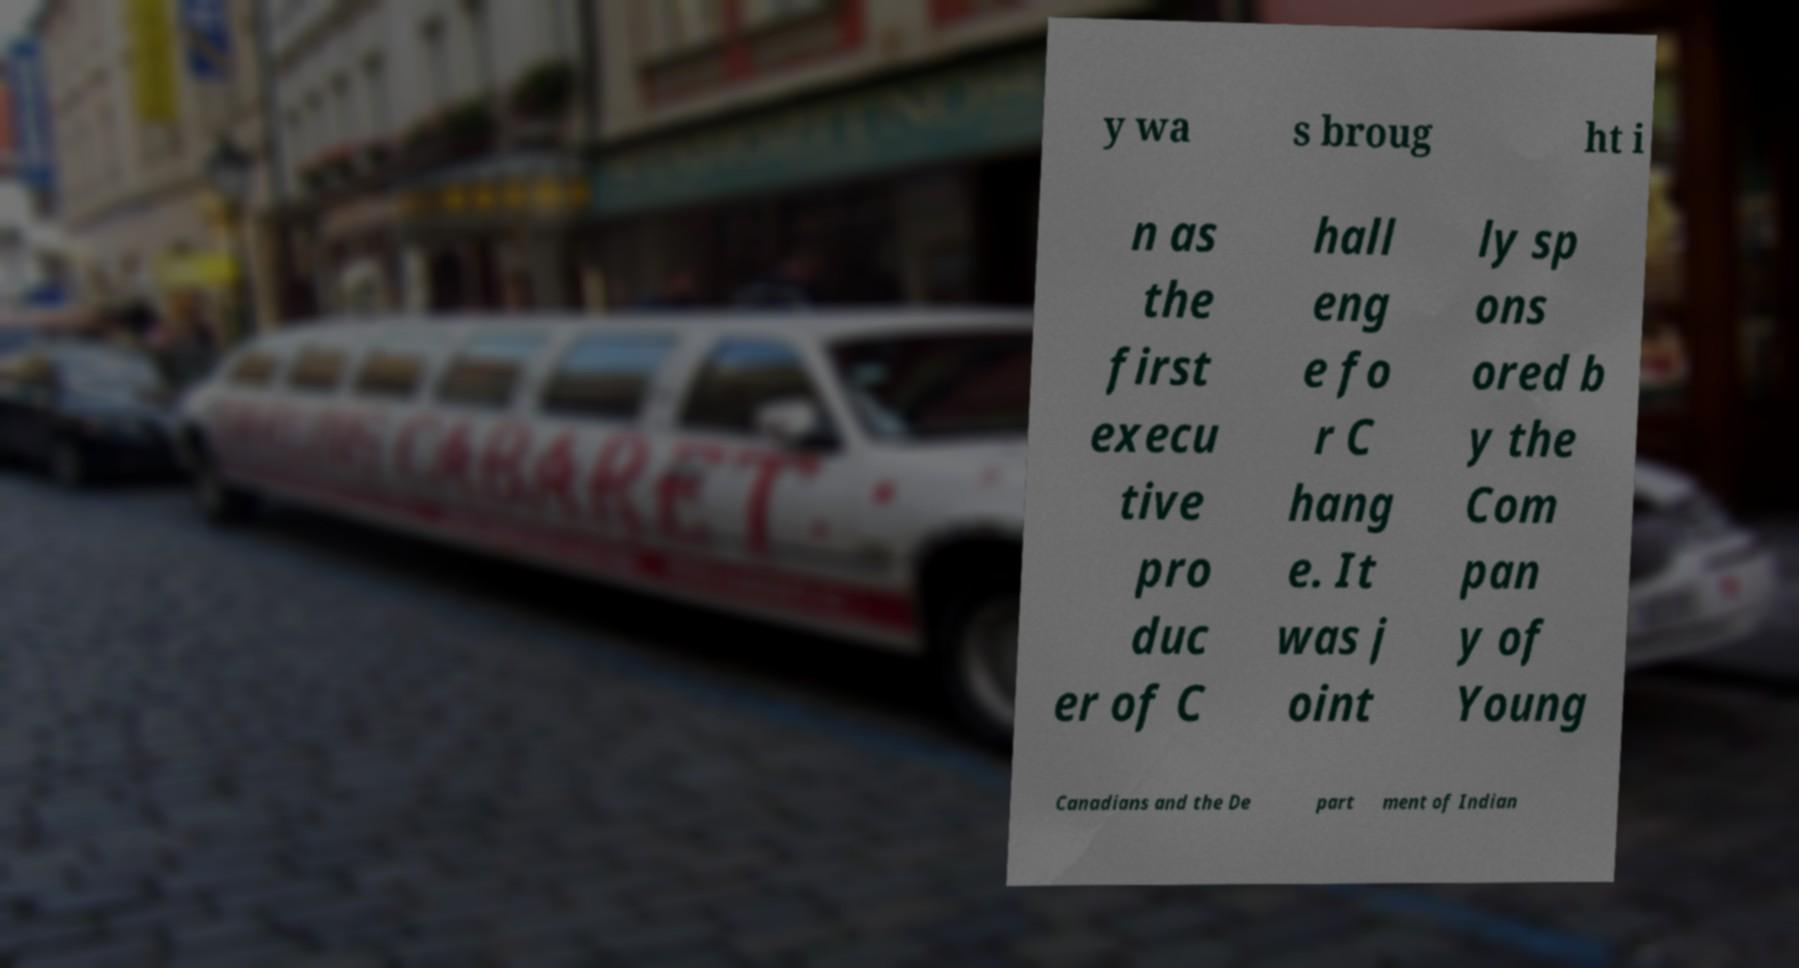Please identify and transcribe the text found in this image. y wa s broug ht i n as the first execu tive pro duc er of C hall eng e fo r C hang e. It was j oint ly sp ons ored b y the Com pan y of Young Canadians and the De part ment of Indian 